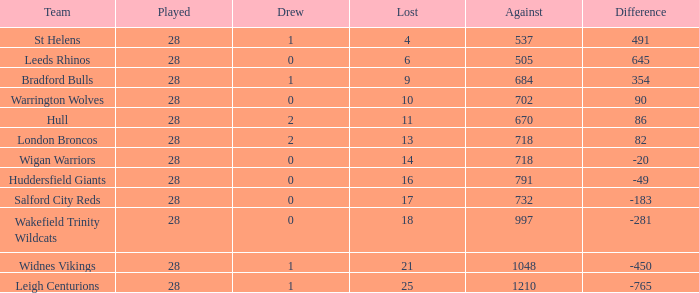Could you parse the entire table as a dict? {'header': ['Team', 'Played', 'Drew', 'Lost', 'Against', 'Difference'], 'rows': [['St Helens', '28', '1', '4', '537', '491'], ['Leeds Rhinos', '28', '0', '6', '505', '645'], ['Bradford Bulls', '28', '1', '9', '684', '354'], ['Warrington Wolves', '28', '0', '10', '702', '90'], ['Hull', '28', '2', '11', '670', '86'], ['London Broncos', '28', '2', '13', '718', '82'], ['Wigan Warriors', '28', '0', '14', '718', '-20'], ['Huddersfield Giants', '28', '0', '16', '791', '-49'], ['Salford City Reds', '28', '0', '17', '732', '-183'], ['Wakefield Trinity Wildcats', '28', '0', '18', '997', '-281'], ['Widnes Vikings', '28', '1', '21', '1048', '-450'], ['Leigh Centurions', '28', '1', '25', '1210', '-765']]} What is the highest difference for the team that had less than 0 draws? None. 